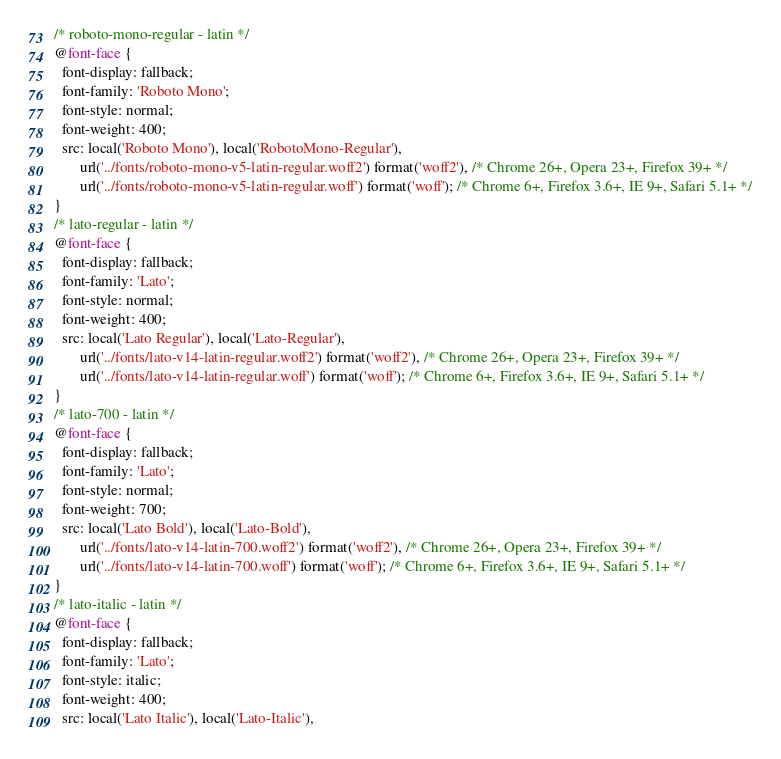<code> <loc_0><loc_0><loc_500><loc_500><_CSS_>/* roboto-mono-regular - latin */
@font-face {
  font-display: fallback;
  font-family: 'Roboto Mono';
  font-style: normal;
  font-weight: 400;
  src: local('Roboto Mono'), local('RobotoMono-Regular'),
       url('../fonts/roboto-mono-v5-latin-regular.woff2') format('woff2'), /* Chrome 26+, Opera 23+, Firefox 39+ */
       url('../fonts/roboto-mono-v5-latin-regular.woff') format('woff'); /* Chrome 6+, Firefox 3.6+, IE 9+, Safari 5.1+ */
}
/* lato-regular - latin */
@font-face {
  font-display: fallback;
  font-family: 'Lato';
  font-style: normal;
  font-weight: 400;
  src: local('Lato Regular'), local('Lato-Regular'),
       url('../fonts/lato-v14-latin-regular.woff2') format('woff2'), /* Chrome 26+, Opera 23+, Firefox 39+ */
       url('../fonts/lato-v14-latin-regular.woff') format('woff'); /* Chrome 6+, Firefox 3.6+, IE 9+, Safari 5.1+ */
}
/* lato-700 - latin */
@font-face {
  font-display: fallback;
  font-family: 'Lato';
  font-style: normal;
  font-weight: 700;
  src: local('Lato Bold'), local('Lato-Bold'),
       url('../fonts/lato-v14-latin-700.woff2') format('woff2'), /* Chrome 26+, Opera 23+, Firefox 39+ */
       url('../fonts/lato-v14-latin-700.woff') format('woff'); /* Chrome 6+, Firefox 3.6+, IE 9+, Safari 5.1+ */
}
/* lato-italic - latin */
@font-face {
  font-display: fallback;
  font-family: 'Lato';
  font-style: italic;
  font-weight: 400;
  src: local('Lato Italic'), local('Lato-Italic'),</code> 